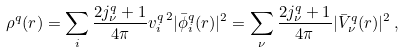<formula> <loc_0><loc_0><loc_500><loc_500>\rho ^ { q } ( r ) = \sum _ { i } \frac { 2 j ^ { q } _ { \nu } + 1 } { 4 \pi } v ^ { q \, 2 } _ { i } | \bar { \phi } ^ { q } _ { i } ( r ) | ^ { 2 } = \sum _ { \nu } \frac { 2 j ^ { q } _ { \nu } + 1 } { 4 \pi } | \bar { V } ^ { q } _ { \nu } ( r ) | ^ { 2 } \, ,</formula> 